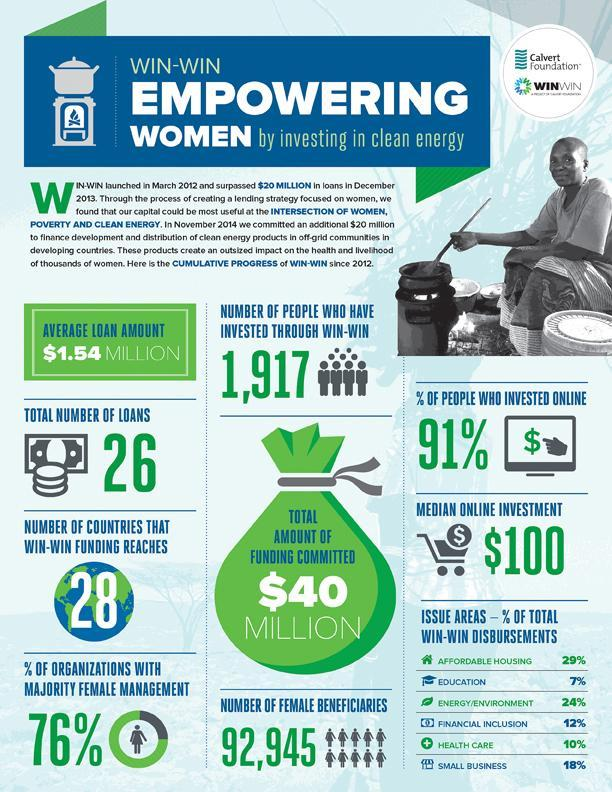What is the total amount of funding committed?
Answer the question with a short phrase. $40 Million What is the percentage of total win-win disbursements in education and health care, taken together? 17% What is the percentage of organizations with a majority of female management? 76% 